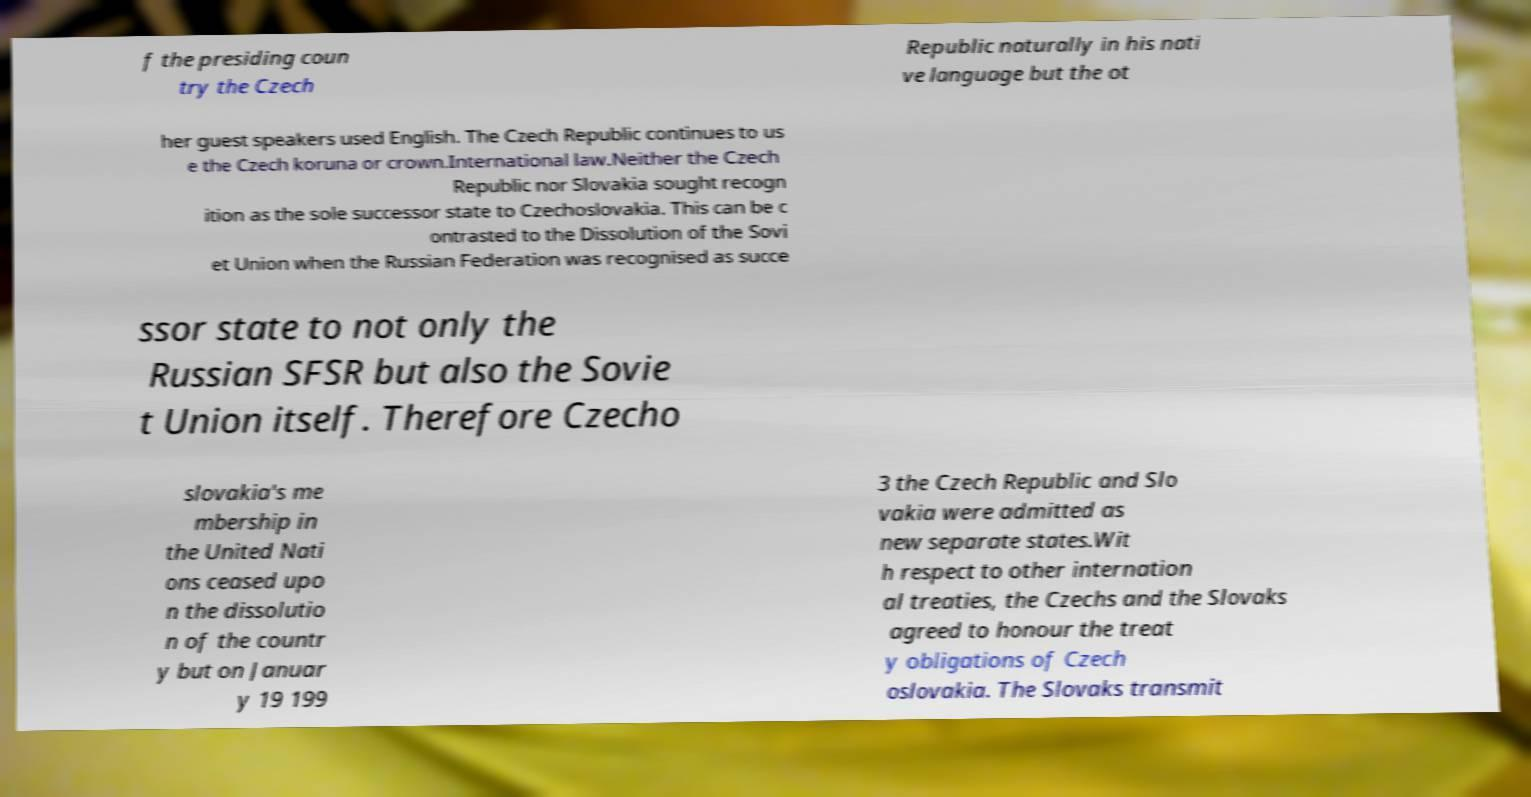I need the written content from this picture converted into text. Can you do that? f the presiding coun try the Czech Republic naturally in his nati ve language but the ot her guest speakers used English. The Czech Republic continues to us e the Czech koruna or crown.International law.Neither the Czech Republic nor Slovakia sought recogn ition as the sole successor state to Czechoslovakia. This can be c ontrasted to the Dissolution of the Sovi et Union when the Russian Federation was recognised as succe ssor state to not only the Russian SFSR but also the Sovie t Union itself. Therefore Czecho slovakia's me mbership in the United Nati ons ceased upo n the dissolutio n of the countr y but on Januar y 19 199 3 the Czech Republic and Slo vakia were admitted as new separate states.Wit h respect to other internation al treaties, the Czechs and the Slovaks agreed to honour the treat y obligations of Czech oslovakia. The Slovaks transmit 